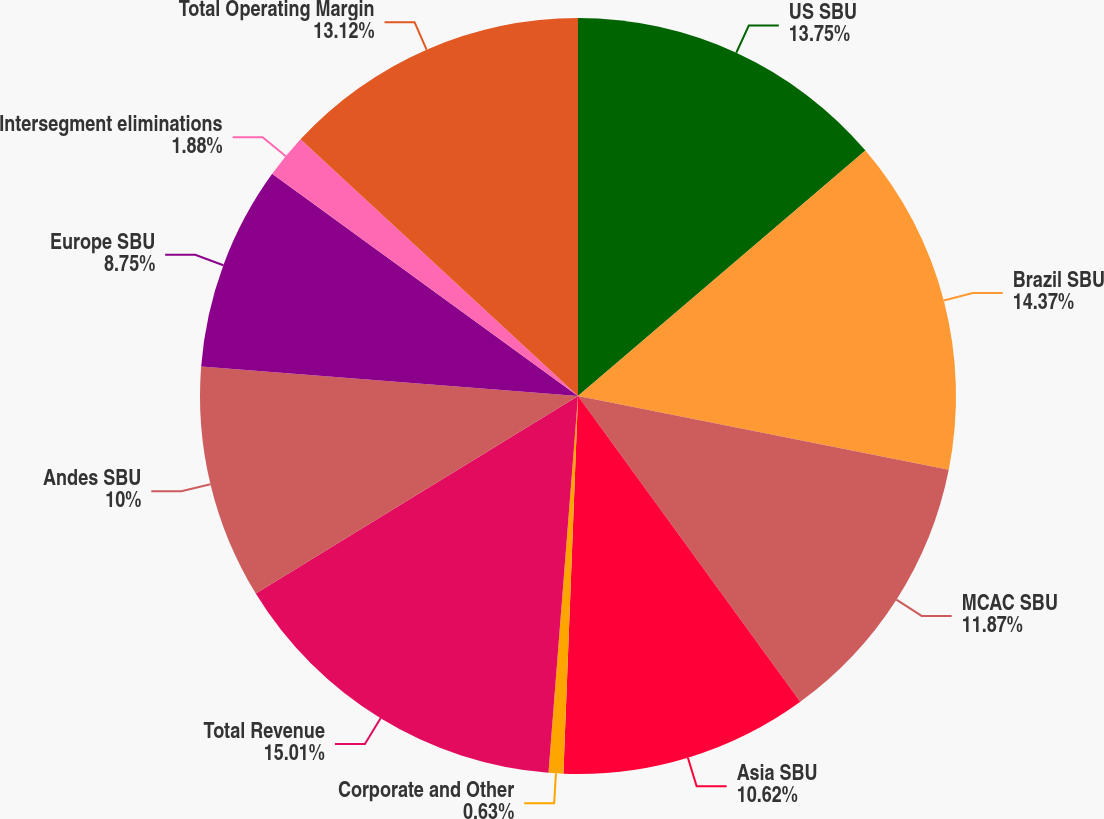<chart> <loc_0><loc_0><loc_500><loc_500><pie_chart><fcel>US SBU<fcel>Brazil SBU<fcel>MCAC SBU<fcel>Asia SBU<fcel>Corporate and Other<fcel>Total Revenue<fcel>Andes SBU<fcel>Europe SBU<fcel>Intersegment eliminations<fcel>Total Operating Margin<nl><fcel>13.75%<fcel>14.37%<fcel>11.87%<fcel>10.62%<fcel>0.63%<fcel>15.0%<fcel>10.0%<fcel>8.75%<fcel>1.88%<fcel>13.12%<nl></chart> 